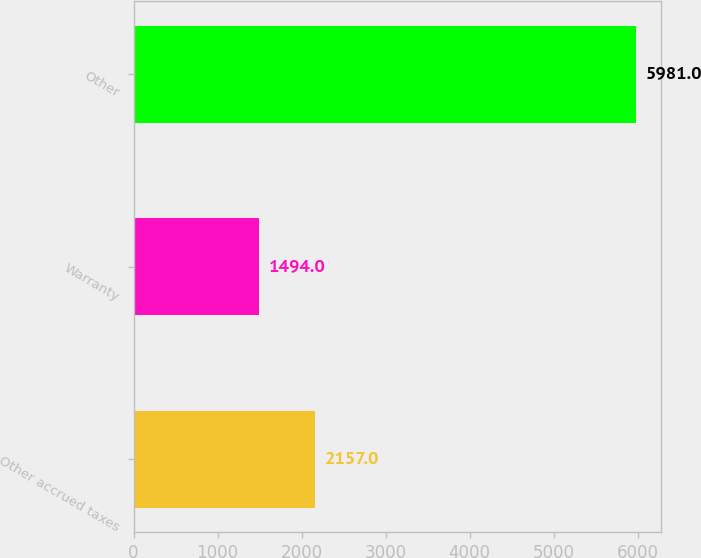<chart> <loc_0><loc_0><loc_500><loc_500><bar_chart><fcel>Other accrued taxes<fcel>Warranty<fcel>Other<nl><fcel>2157<fcel>1494<fcel>5981<nl></chart> 